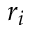<formula> <loc_0><loc_0><loc_500><loc_500>r _ { i }</formula> 